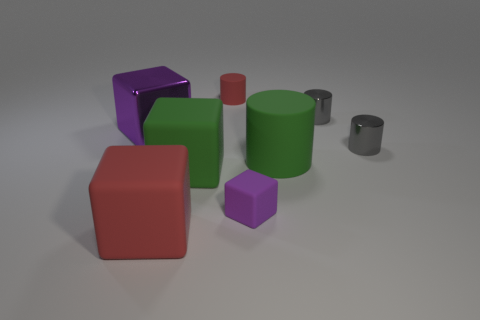Add 2 big matte cylinders. How many objects exist? 10 Subtract 0 red spheres. How many objects are left? 8 Subtract all small cylinders. Subtract all small purple matte objects. How many objects are left? 4 Add 4 big red matte things. How many big red matte things are left? 5 Add 5 purple cubes. How many purple cubes exist? 7 